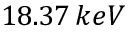<formula> <loc_0><loc_0><loc_500><loc_500>1 8 . 3 7 \, k e V</formula> 